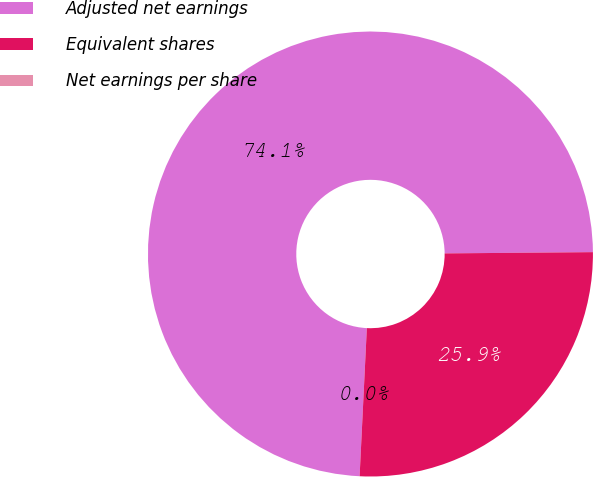<chart> <loc_0><loc_0><loc_500><loc_500><pie_chart><fcel>Adjusted net earnings<fcel>Equivalent shares<fcel>Net earnings per share<nl><fcel>74.09%<fcel>25.91%<fcel>0.0%<nl></chart> 